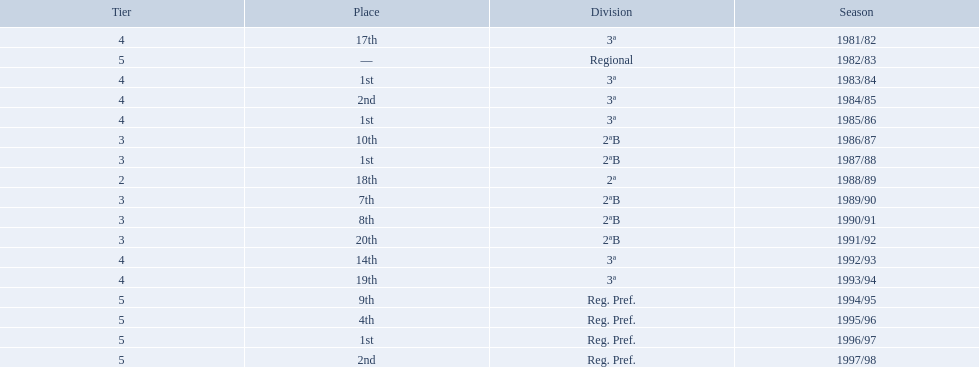Which years did the team have a season? 1981/82, 1982/83, 1983/84, 1984/85, 1985/86, 1986/87, 1987/88, 1988/89, 1989/90, 1990/91, 1991/92, 1992/93, 1993/94, 1994/95, 1995/96, 1996/97, 1997/98. Which of those years did the team place outside the top 10? 1981/82, 1988/89, 1991/92, 1992/93, 1993/94. Which of the years in which the team placed outside the top 10 did they have their worst performance? 1991/92. 